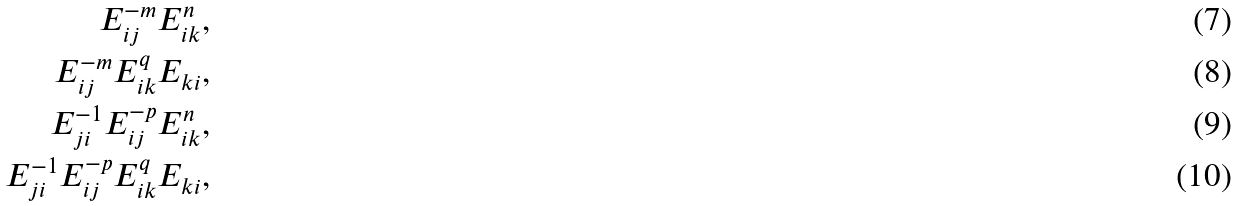Convert formula to latex. <formula><loc_0><loc_0><loc_500><loc_500>E _ { i j } ^ { - m } E _ { i k } ^ { n } , \\ E _ { i j } ^ { - m } E _ { i k } ^ { q } E _ { k i } , \\ E _ { j i } ^ { - 1 } E _ { i j } ^ { - p } E _ { i k } ^ { n } , \\ E _ { j i } ^ { - 1 } E _ { i j } ^ { - p } E _ { i k } ^ { q } E _ { k i } ,</formula> 